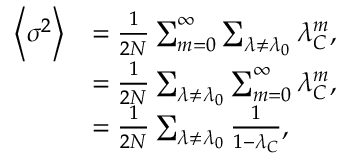<formula> <loc_0><loc_0><loc_500><loc_500>\begin{array} { r l } { \left \langle \sigma ^ { 2 } \right \rangle } & { = \frac { 1 } { 2 N } \sum _ { m = 0 } ^ { \infty } \sum _ { \lambda \neq \lambda _ { 0 } } { \lambda _ { C } ^ { m } } , } \\ & { = \frac { 1 } { 2 N } \sum _ { \lambda \neq \lambda _ { 0 } } \sum _ { m = 0 } ^ { \infty } { \lambda _ { C } ^ { m } } , } \\ & { = \frac { 1 } { 2 N } \sum _ { \lambda \neq \lambda _ { 0 } } \frac { 1 } { 1 - \lambda _ { C } } , } \end{array}</formula> 